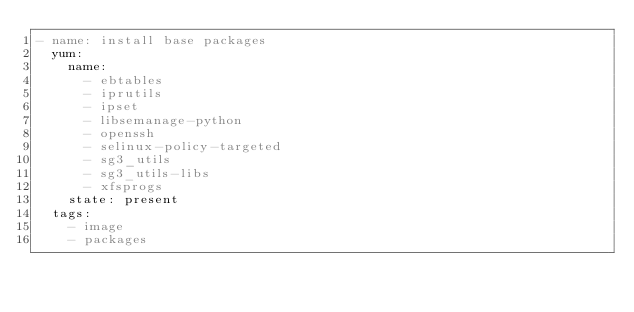Convert code to text. <code><loc_0><loc_0><loc_500><loc_500><_YAML_>- name: install base packages
  yum:
    name:
      - ebtables
      - iprutils
      - ipset
      - libsemanage-python
      - openssh
      - selinux-policy-targeted
      - sg3_utils
      - sg3_utils-libs
      - xfsprogs
    state: present
  tags:
    - image
    - packages

</code> 